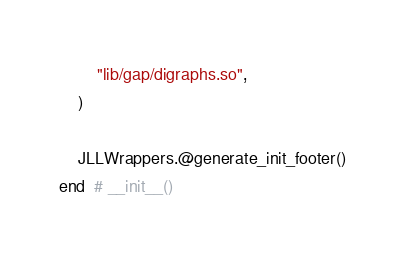<code> <loc_0><loc_0><loc_500><loc_500><_Julia_>        "lib/gap/digraphs.so",
    )

    JLLWrappers.@generate_init_footer()
end  # __init__()
</code> 